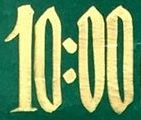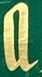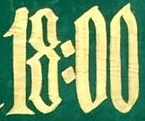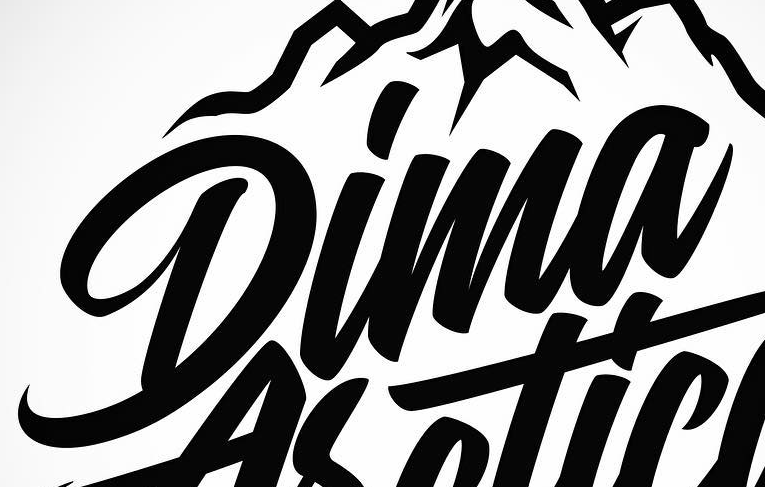Transcribe the words shown in these images in order, separated by a semicolon. 10:00; a; 18:00; Dima 